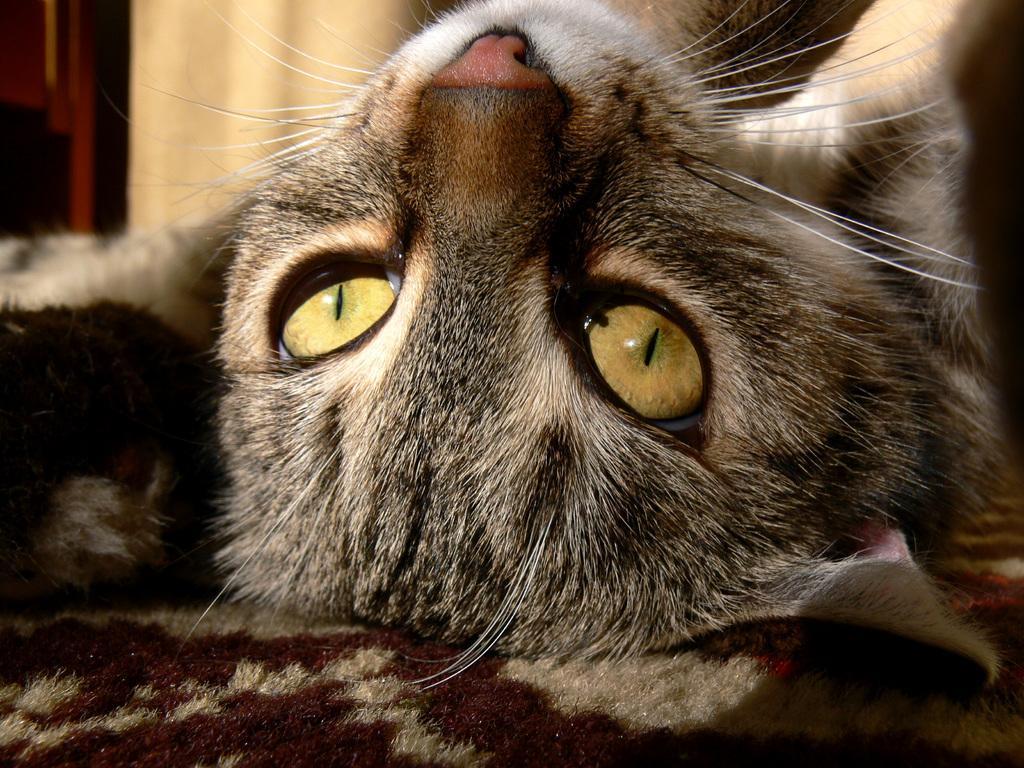Can you describe this image briefly? This image is taken indoors. In the background there is a wall. In the middle of the image there is a cat lying on the towel. 